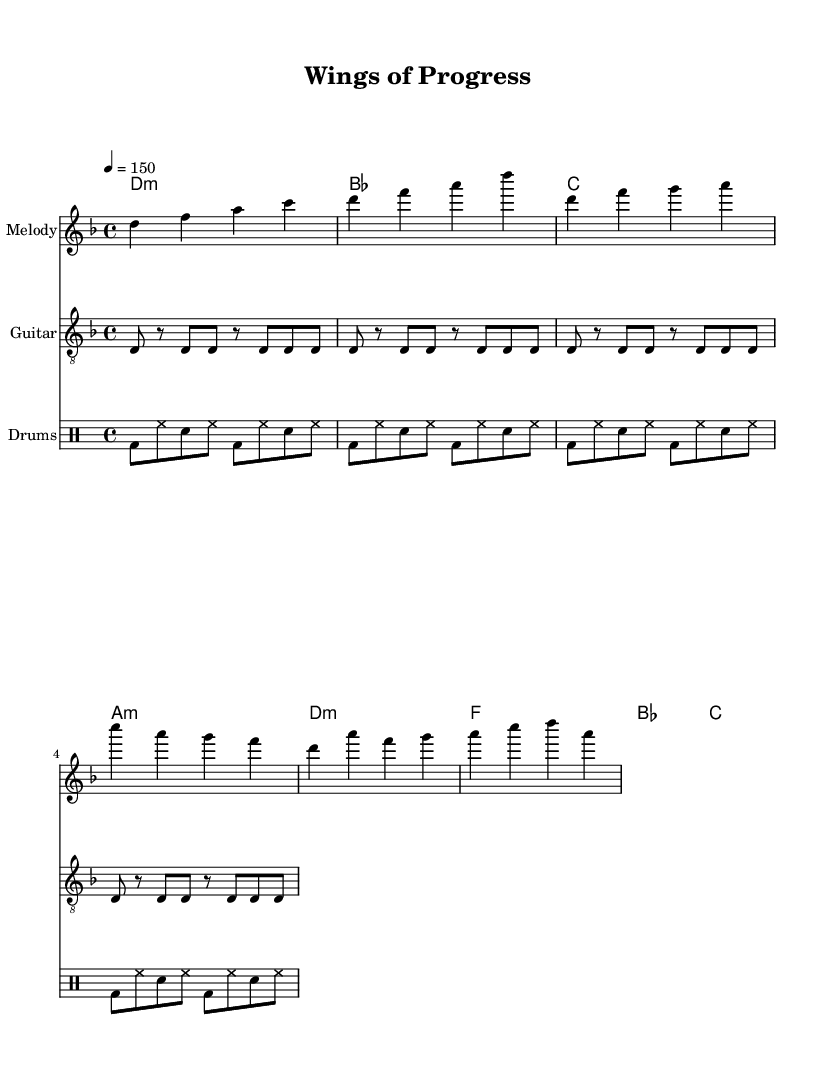What is the key signature of this music? The key signature is indicated by the "d" sign, and since it has one flat (B), it is in D minor.
Answer: D minor What is the time signature of this piece? The time signature is represented as "4/4," which indicates four beats in each measure.
Answer: 4/4 What is the tempo marking in this score? The tempo marking is specified as "4 = 150," indicating that there are 150 beats per minute, and each quarter note gets one beat.
Answer: 150 How many measures are in the verse section? The verse section contains a series of notes and rests; counting the complete measures, there are four measures in the verse.
Answer: 4 What type of harmony is primarily used in the verse? Looking at the chords in the verse, they show that it is based on minor chords and resolutions typical of rock and metal. The primary harmony used here is D minor.
Answer: D minor What is the lyrical theme of this piece? The lyrics discuss themes related to aviation technology and historical advancements in flight, reflecting the inspirations of the symphonic metal genre.
Answer: Aviation history What kind of instrument is indicated for the rhythm guitar part? The score specifies the rhythm guitar to be played in a "treble_8" clef, indicating it is written in a higher pitch suitable for guitar.
Answer: Treble 